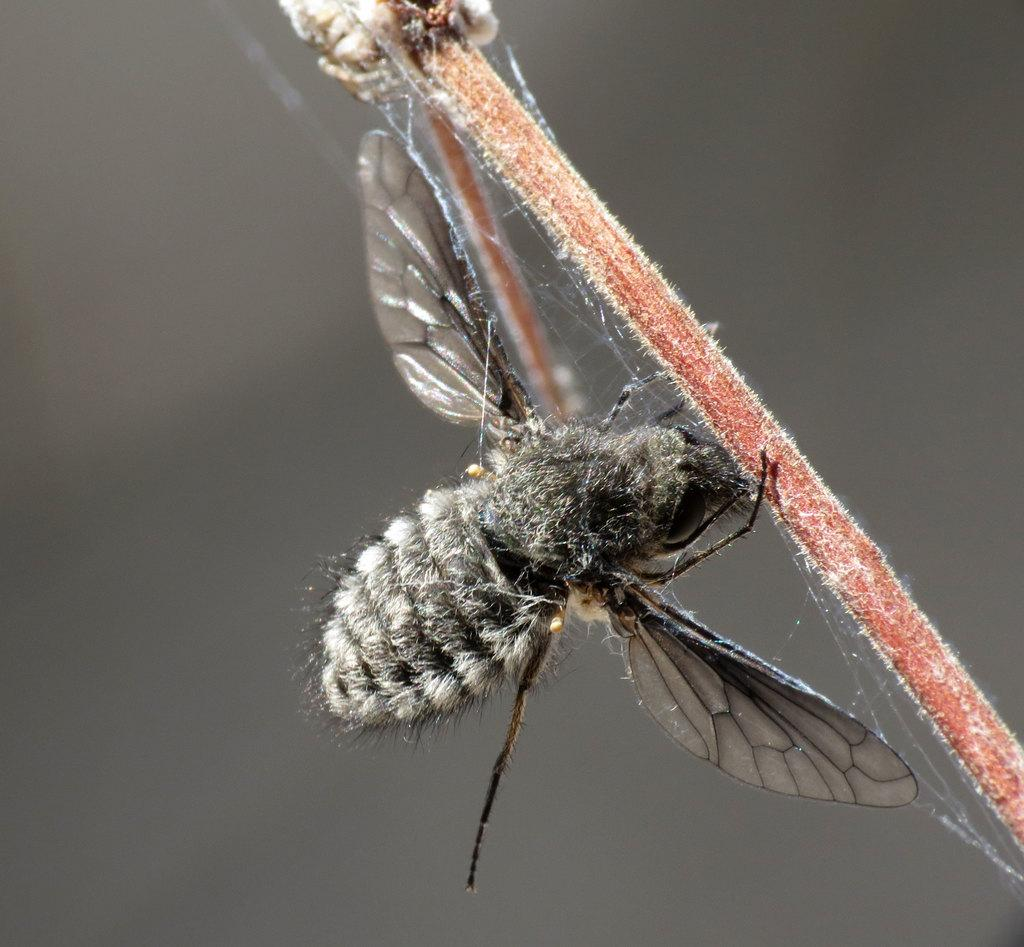What is present in the image? There is an insect in the image. Where is the insect located? The insect is on the stem of a plant. What type of cub can be seen playing with the plant in the image? There is no cub present in the image, and the insect is not playing with the plant. 